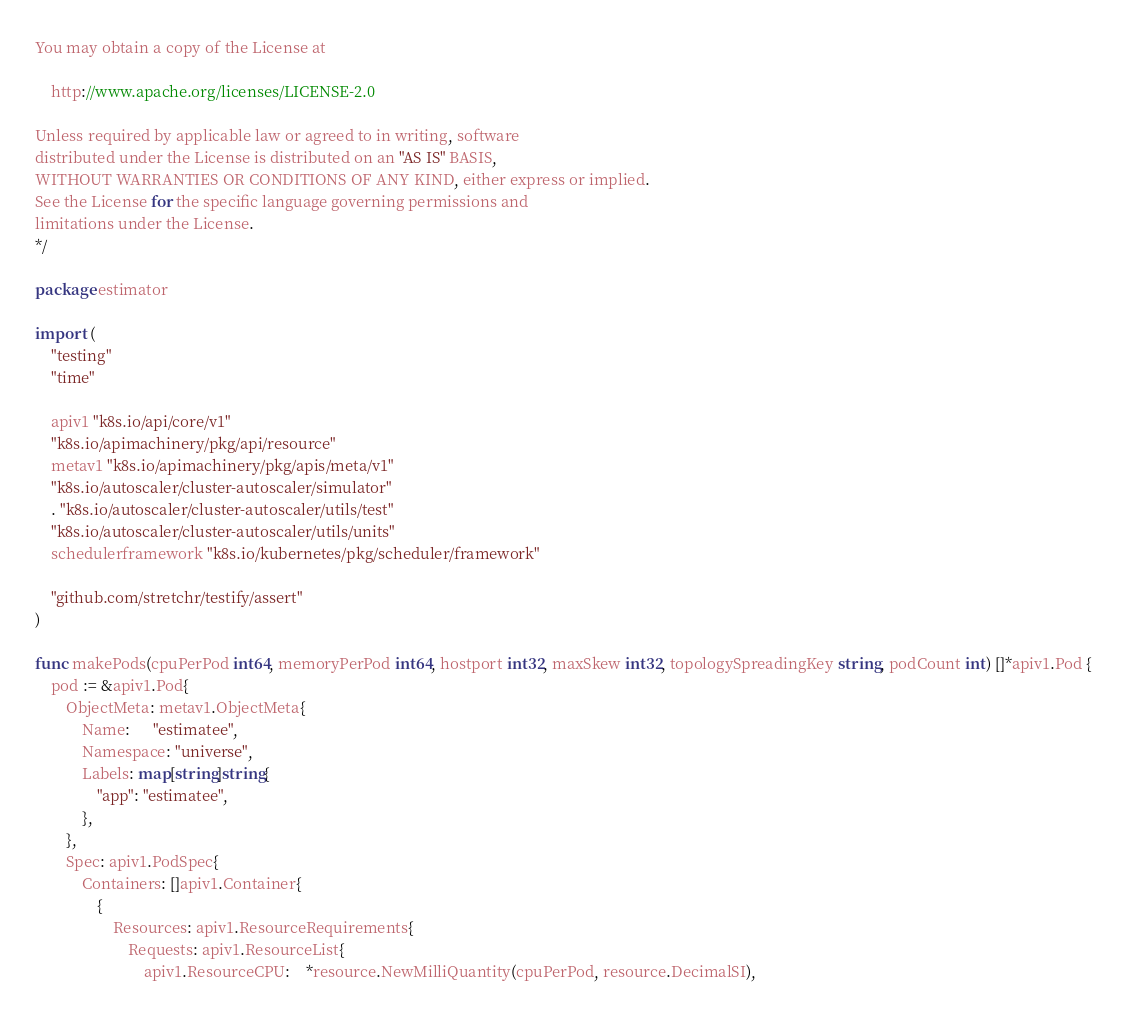Convert code to text. <code><loc_0><loc_0><loc_500><loc_500><_Go_>You may obtain a copy of the License at

    http://www.apache.org/licenses/LICENSE-2.0

Unless required by applicable law or agreed to in writing, software
distributed under the License is distributed on an "AS IS" BASIS,
WITHOUT WARRANTIES OR CONDITIONS OF ANY KIND, either express or implied.
See the License for the specific language governing permissions and
limitations under the License.
*/

package estimator

import (
	"testing"
	"time"

	apiv1 "k8s.io/api/core/v1"
	"k8s.io/apimachinery/pkg/api/resource"
	metav1 "k8s.io/apimachinery/pkg/apis/meta/v1"
	"k8s.io/autoscaler/cluster-autoscaler/simulator"
	. "k8s.io/autoscaler/cluster-autoscaler/utils/test"
	"k8s.io/autoscaler/cluster-autoscaler/utils/units"
	schedulerframework "k8s.io/kubernetes/pkg/scheduler/framework"

	"github.com/stretchr/testify/assert"
)

func makePods(cpuPerPod int64, memoryPerPod int64, hostport int32, maxSkew int32, topologySpreadingKey string, podCount int) []*apiv1.Pod {
	pod := &apiv1.Pod{
		ObjectMeta: metav1.ObjectMeta{
			Name:      "estimatee",
			Namespace: "universe",
			Labels: map[string]string{
				"app": "estimatee",
			},
		},
		Spec: apiv1.PodSpec{
			Containers: []apiv1.Container{
				{
					Resources: apiv1.ResourceRequirements{
						Requests: apiv1.ResourceList{
							apiv1.ResourceCPU:    *resource.NewMilliQuantity(cpuPerPod, resource.DecimalSI),</code> 